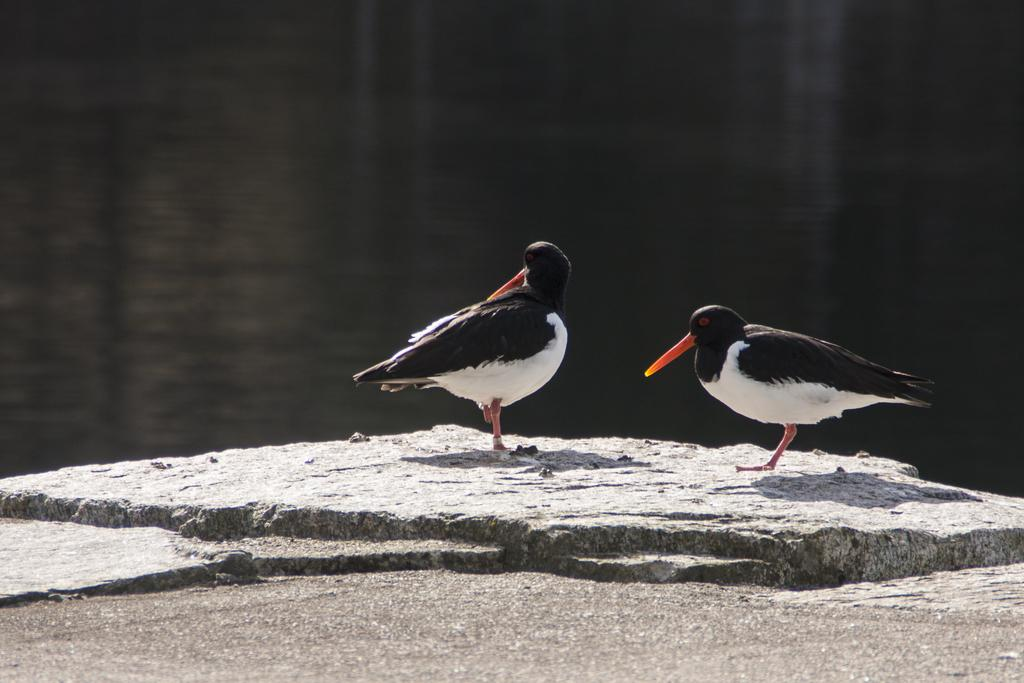What type of animals can be seen in the image? There are birds in the image. Where are the birds located? The birds are on a rock. What can be seen in the background of the image? There is water visible in the background of the image. What type of van can be seen in the image? There is no van present in the image; it features birds on a rock with water visible in the background. 